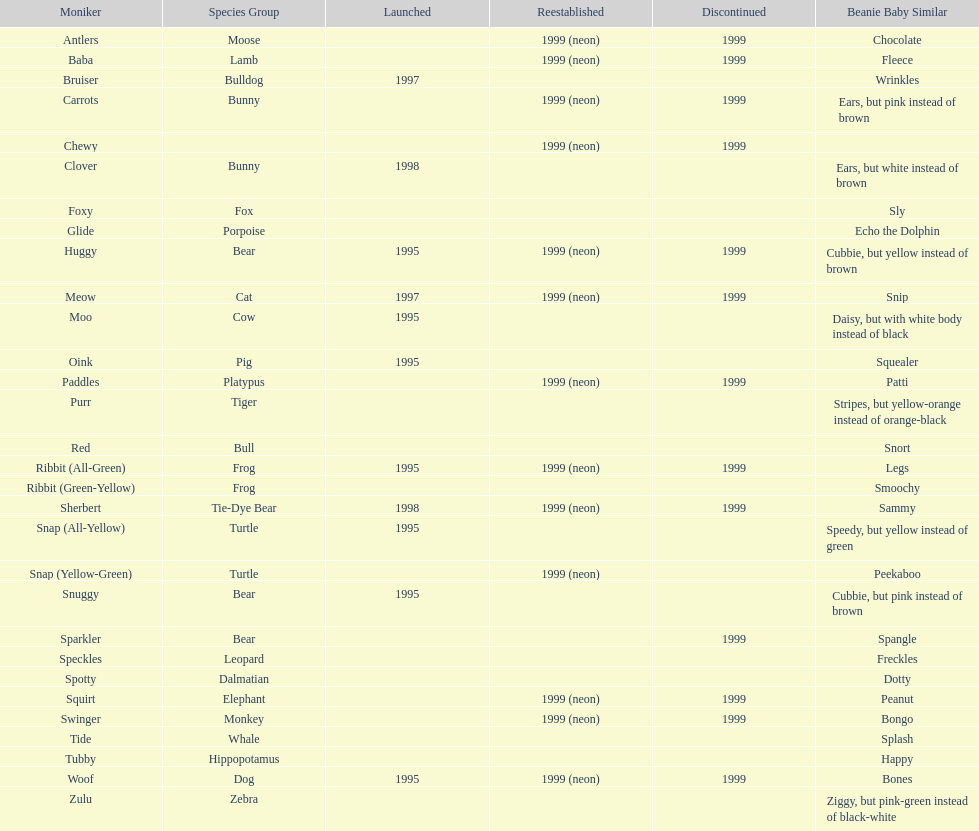What is the name of the last pillow pal on this chart? Zulu. 